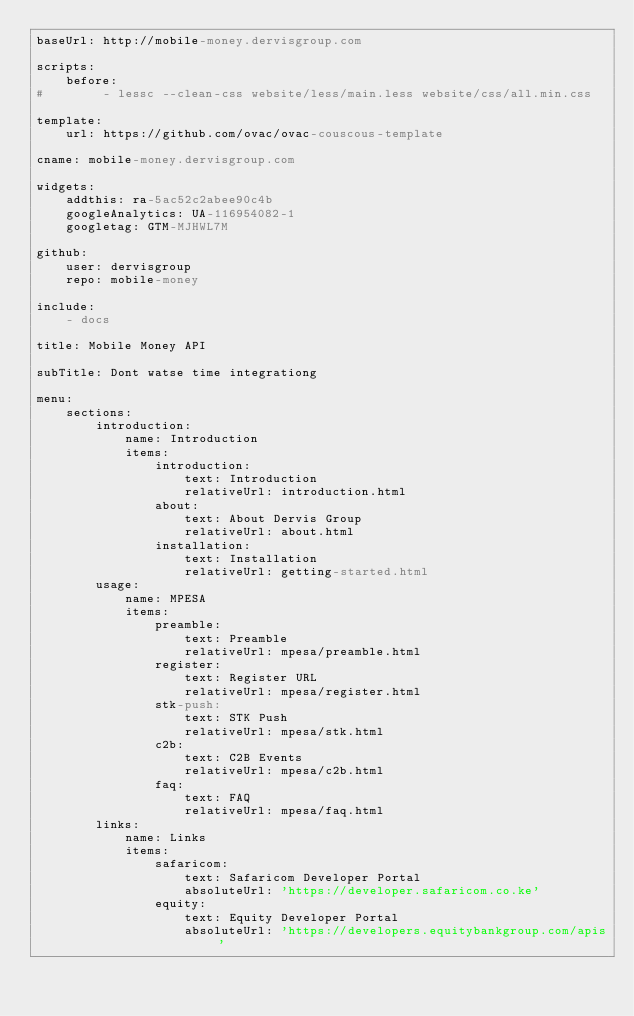Convert code to text. <code><loc_0><loc_0><loc_500><loc_500><_YAML_>baseUrl: http://mobile-money.dervisgroup.com

scripts:
    before:
#        - lessc --clean-css website/less/main.less website/css/all.min.css

template:
    url: https://github.com/ovac/ovac-couscous-template

cname: mobile-money.dervisgroup.com

widgets:
    addthis: ra-5ac52c2abee90c4b
    googleAnalytics: UA-116954082-1
    googletag: GTM-MJHWL7M

github:
    user: dervisgroup
    repo: mobile-money

include:
    - docs

title: Mobile Money API

subTitle: Dont watse time integrationg

menu:
    sections:
        introduction:
            name: Introduction
            items:
                introduction:
                    text: Introduction
                    relativeUrl: introduction.html
                about:
                    text: About Dervis Group
                    relativeUrl: about.html
                installation:
                    text: Installation
                    relativeUrl: getting-started.html
        usage:
            name: MPESA
            items:
                preamble:
                    text: Preamble
                    relativeUrl: mpesa/preamble.html
                register:
                    text: Register URL
                    relativeUrl: mpesa/register.html
                stk-push:
                    text: STK Push
                    relativeUrl: mpesa/stk.html
                c2b:
                    text: C2B Events
                    relativeUrl: mpesa/c2b.html
                faq:
                    text: FAQ
                    relativeUrl: mpesa/faq.html
        links:
            name: Links
            items:
                safaricom:
                    text: Safaricom Developer Portal
                    absoluteUrl: 'https://developer.safaricom.co.ke'
                equity:
                    text: Equity Developer Portal
                    absoluteUrl: 'https://developers.equitybankgroup.com/apis'
</code> 